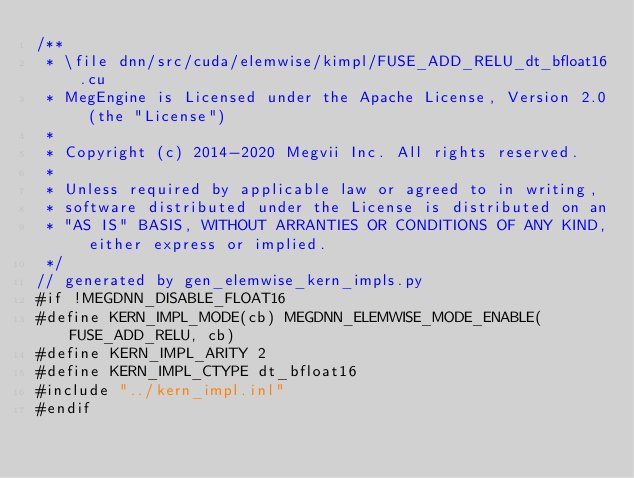Convert code to text. <code><loc_0><loc_0><loc_500><loc_500><_Cuda_>/**
 * \file dnn/src/cuda/elemwise/kimpl/FUSE_ADD_RELU_dt_bfloat16.cu
 * MegEngine is Licensed under the Apache License, Version 2.0 (the "License")
 *
 * Copyright (c) 2014-2020 Megvii Inc. All rights reserved.
 *
 * Unless required by applicable law or agreed to in writing,
 * software distributed under the License is distributed on an
 * "AS IS" BASIS, WITHOUT ARRANTIES OR CONDITIONS OF ANY KIND, either express or implied.
 */
// generated by gen_elemwise_kern_impls.py
#if !MEGDNN_DISABLE_FLOAT16
#define KERN_IMPL_MODE(cb) MEGDNN_ELEMWISE_MODE_ENABLE(FUSE_ADD_RELU, cb)
#define KERN_IMPL_ARITY 2
#define KERN_IMPL_CTYPE dt_bfloat16
#include "../kern_impl.inl"
#endif
</code> 